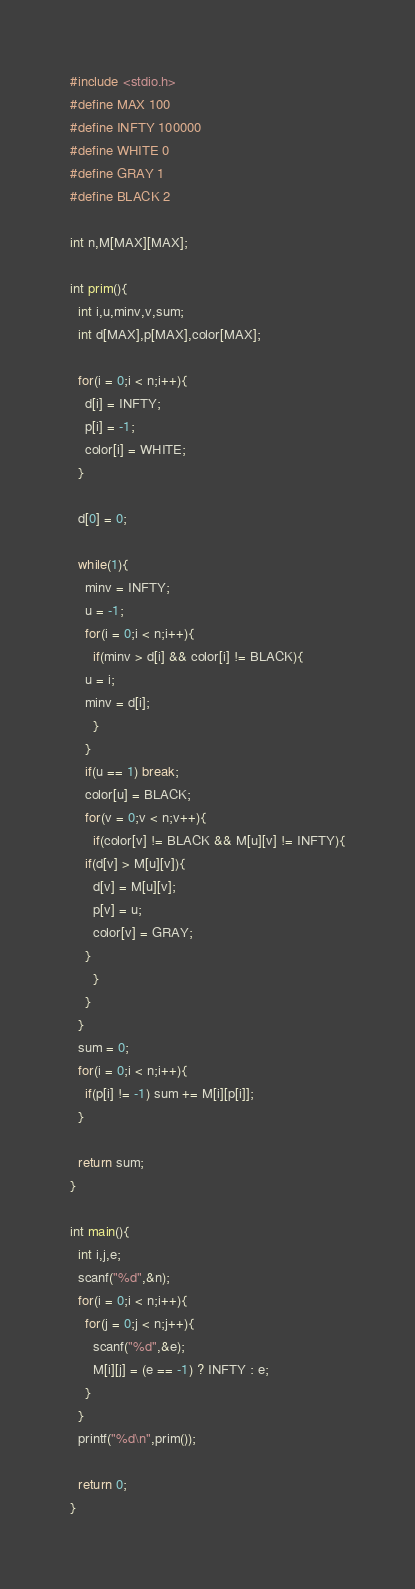Convert code to text. <code><loc_0><loc_0><loc_500><loc_500><_C_>#include <stdio.h>
#define MAX 100
#define INFTY 100000
#define WHITE 0
#define GRAY 1
#define BLACK 2

int n,M[MAX][MAX];

int prim(){
  int i,u,minv,v,sum;
  int d[MAX],p[MAX],color[MAX];

  for(i = 0;i < n;i++){
    d[i] = INFTY;
    p[i] = -1;
    color[i] = WHITE;
  }

  d[0] = 0;

  while(1){
    minv = INFTY;
    u = -1;
    for(i = 0;i < n;i++){
      if(minv > d[i] && color[i] != BLACK){
	u = i;
	minv = d[i];
      }
    }
    if(u == 1) break;
    color[u] = BLACK;
    for(v = 0;v < n;v++){
      if(color[v] != BLACK && M[u][v] != INFTY){
	if(d[v] > M[u][v]){
	  d[v] = M[u][v];
	  p[v] = u;
	  color[v] = GRAY;
	}
      }
    }
  }
  sum = 0;
  for(i = 0;i < n;i++){
    if(p[i] != -1) sum += M[i][p[i]];
  }

  return sum;
}

int main(){
  int i,j,e;
  scanf("%d",&n);
  for(i = 0;i < n;i++){
    for(j = 0;j < n;j++){
      scanf("%d",&e);
      M[i][j] = (e == -1) ? INFTY : e;
    }
  }
  printf("%d\n",prim());

  return 0;
}</code> 